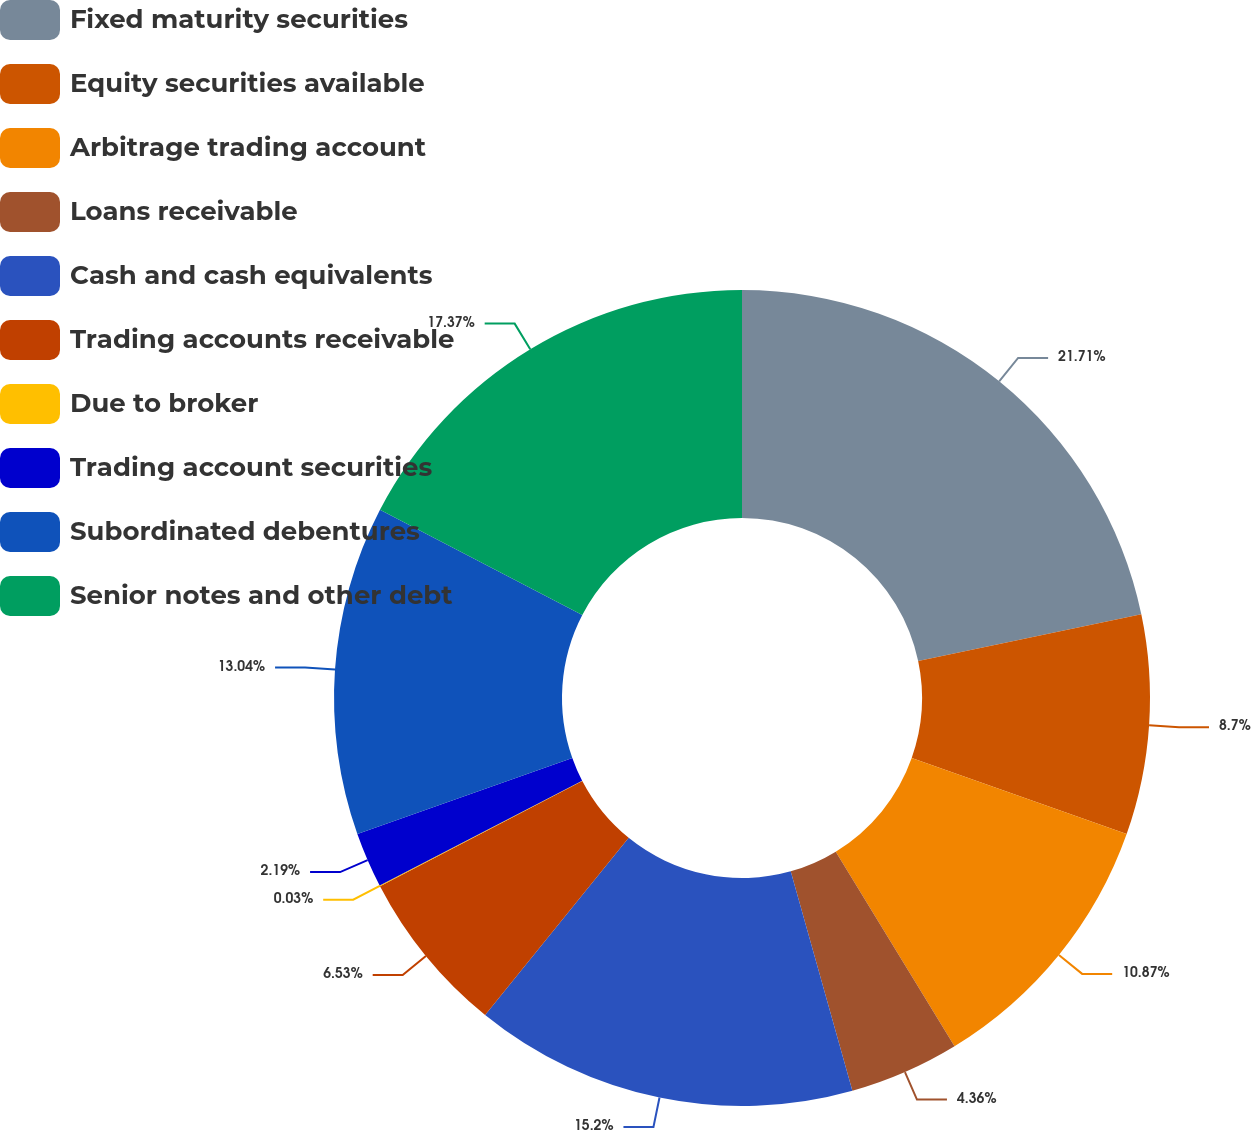<chart> <loc_0><loc_0><loc_500><loc_500><pie_chart><fcel>Fixed maturity securities<fcel>Equity securities available<fcel>Arbitrage trading account<fcel>Loans receivable<fcel>Cash and cash equivalents<fcel>Trading accounts receivable<fcel>Due to broker<fcel>Trading account securities<fcel>Subordinated debentures<fcel>Senior notes and other debt<nl><fcel>21.71%<fcel>8.7%<fcel>10.87%<fcel>4.36%<fcel>15.2%<fcel>6.53%<fcel>0.03%<fcel>2.19%<fcel>13.04%<fcel>17.37%<nl></chart> 